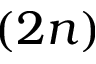Convert formula to latex. <formula><loc_0><loc_0><loc_500><loc_500>( 2 n )</formula> 